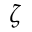<formula> <loc_0><loc_0><loc_500><loc_500>\zeta</formula> 